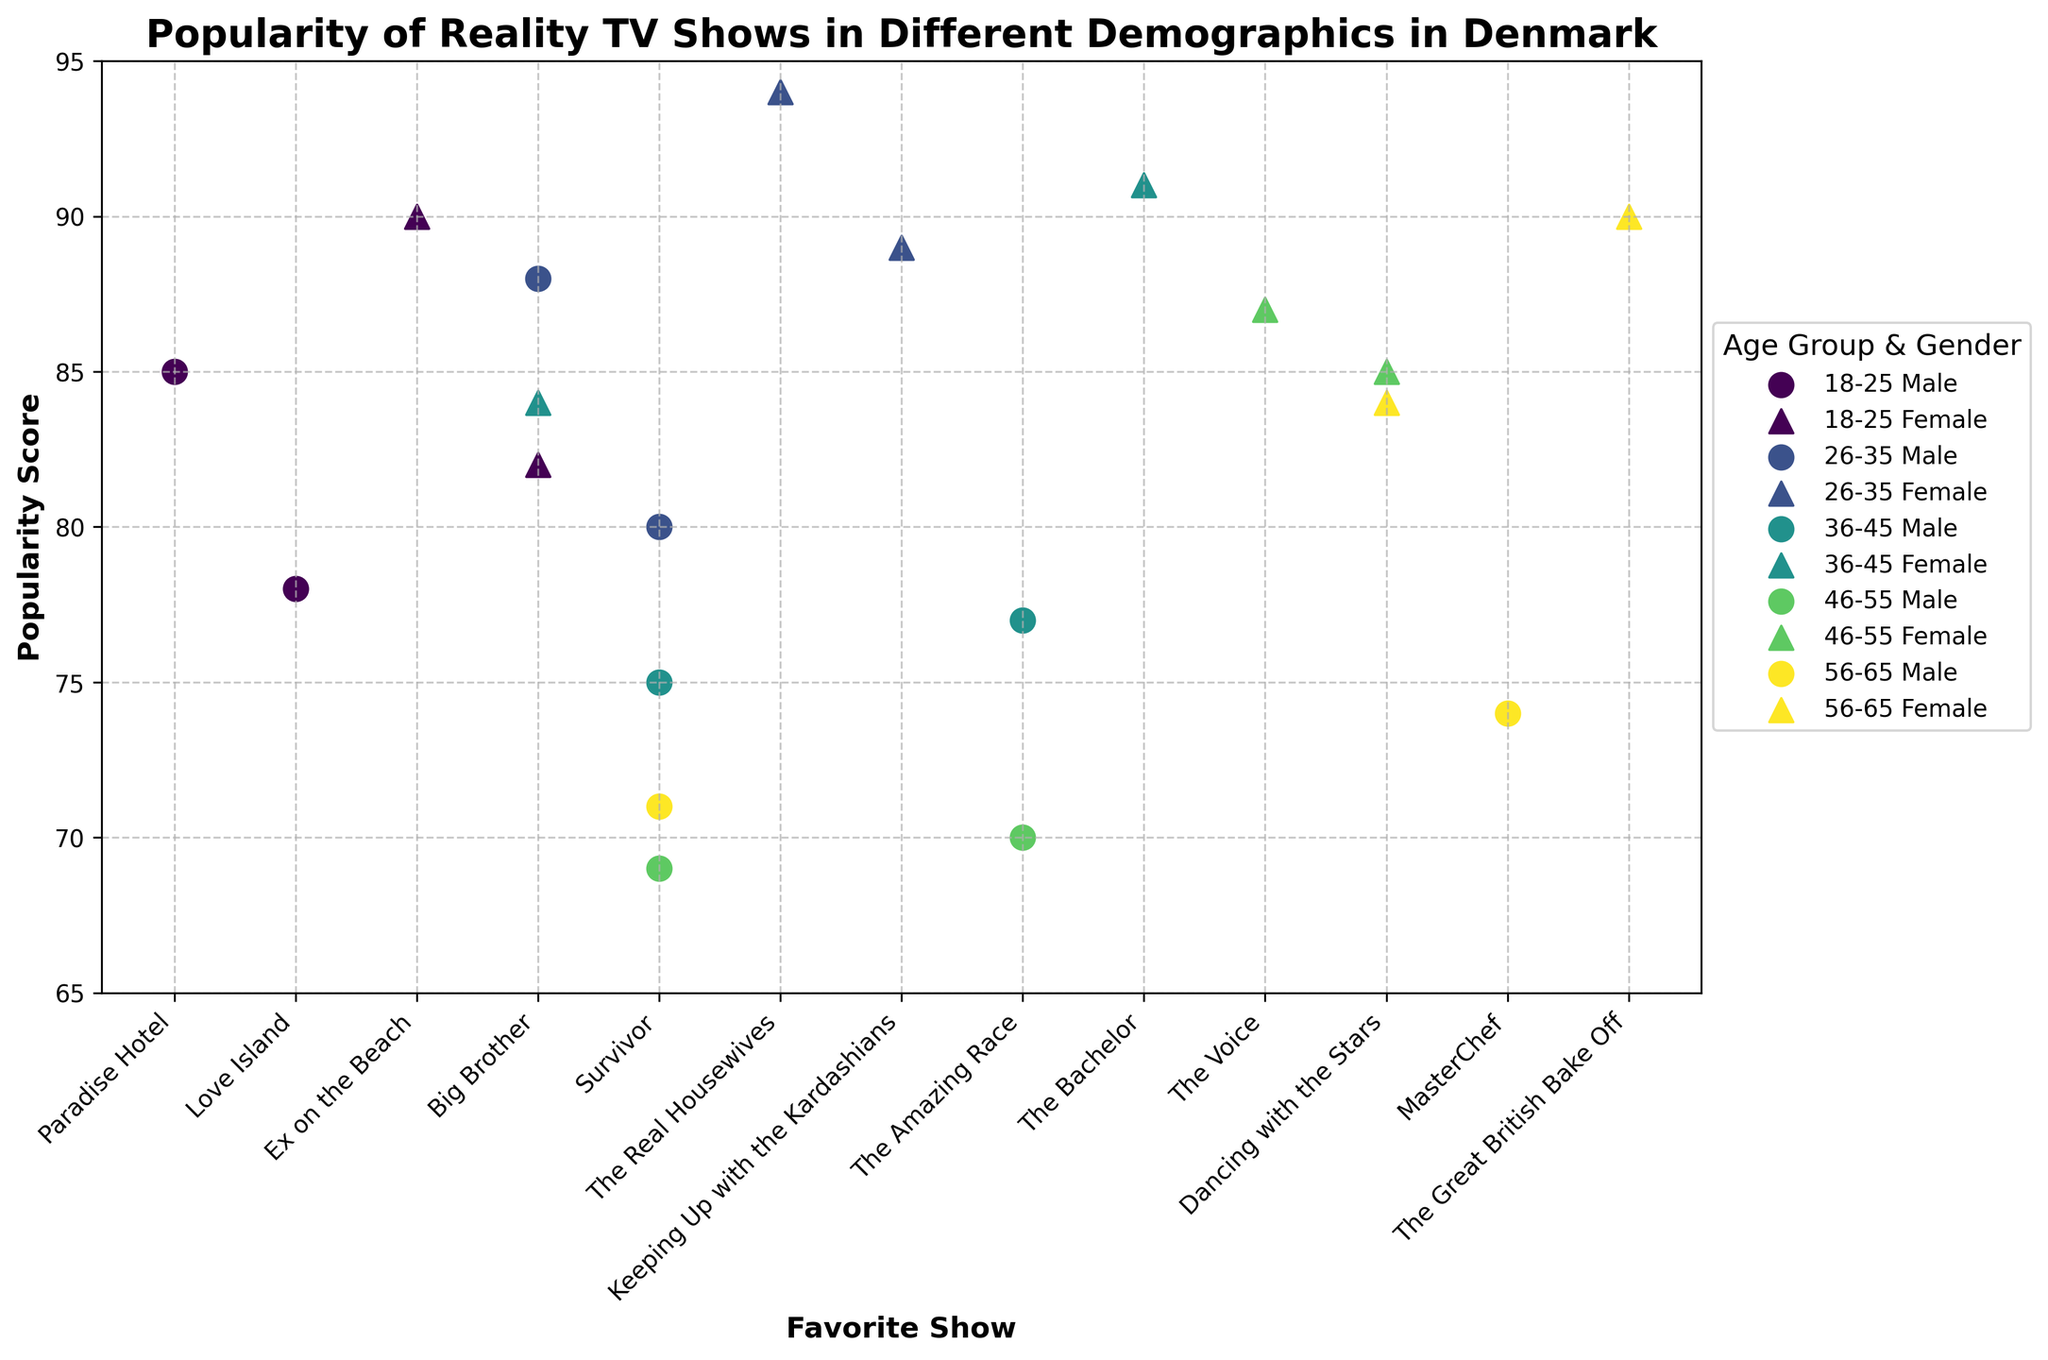What is the title of the figure? The title is typically located at the top of the figure and provides a summary of what the figure represents.
Answer: Popularity of Reality TV Shows in Different Demographics in Denmark What are the labels of the axes? Axis labels describe the data being plotted. The x-axis label is found below the x-axis, and the y-axis label is found beside the y-axis.
Answer: Favorite Show (x-axis), Popularity Score (y-axis) How many age groups are represented in the figure? The number of unique colors or legend entries corresponding to different age groups indicates how many age groups are represented.
Answer: 5 Which age group and gender have the highest popularity score, and for which show? Identify the data point with the highest y-value and refer to its x-coordinate for the favorite show and its legend entry for age group and gender.
Answer: 26-35 Female, The Real Housewives Which age group has the most diverse set of favorite shows? Count the number of unique favorite shows for each age group by examining the unique x-axis values within each group.
Answer: 18-25 Which show is the most popular among females aged 36-45? Locate the data points for females aged 36-45 and identify the point with the highest popularity score.
Answer: The Bachelor How does the popularity score of 'Survivor' change across different age groups for males? 1. Identify all data points for males who prefer 'Survivor'. 2. Note the y-values (popularity scores) and their corresponding age groups.
Answer: 80 (26-35) > 75 (36-45) > 69 (46-55) > 71 (56-65) Is there a show liked by both males and females in any age group? Examine data points within each age group and match shows (x-axis values) that appear for both males and females.
Answer: Big Brother in 18-25 age group 